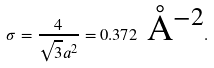Convert formula to latex. <formula><loc_0><loc_0><loc_500><loc_500>\sigma = \frac { 4 } { \sqrt { 3 } a ^ { 2 } } = 0 . 3 7 2 \text { {\AA}$^{-2}$} .</formula> 